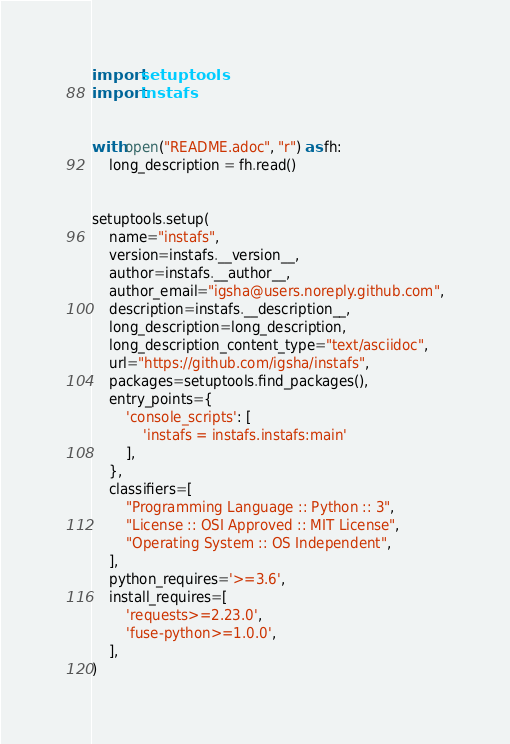Convert code to text. <code><loc_0><loc_0><loc_500><loc_500><_Python_>import setuptools
import instafs


with open("README.adoc", "r") as fh:
    long_description = fh.read()


setuptools.setup(
    name="instafs",
    version=instafs.__version__,
    author=instafs.__author__,
    author_email="igsha@users.noreply.github.com",
    description=instafs.__description__,
    long_description=long_description,
    long_description_content_type="text/asciidoc",
    url="https://github.com/igsha/instafs",
    packages=setuptools.find_packages(),
    entry_points={
        'console_scripts': [
            'instafs = instafs.instafs:main'
        ],
    },
    classifiers=[
        "Programming Language :: Python :: 3",
        "License :: OSI Approved :: MIT License",
        "Operating System :: OS Independent",
    ],
    python_requires='>=3.6',
    install_requires=[
        'requests>=2.23.0',
        'fuse-python>=1.0.0',
    ],
)
</code> 